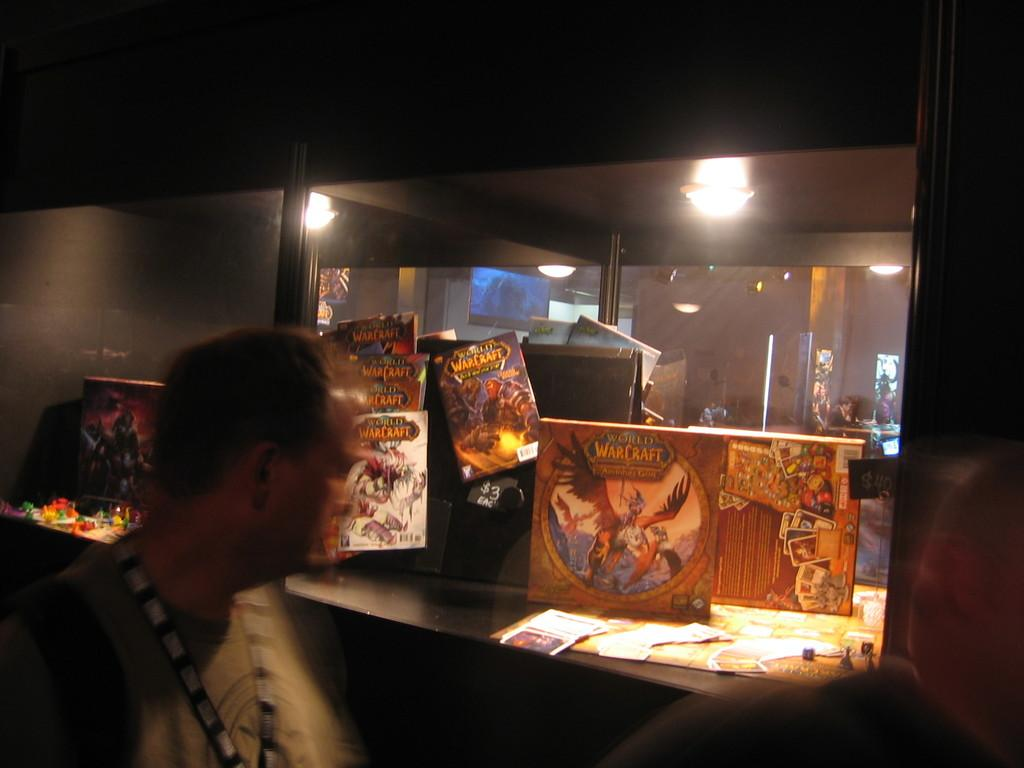What is located on the left side of the image? There is a man standing on the left side of the image, although the blurriness may affect the clarity of this observation. What can be seen in the image besides the man? There are some pictures and a light in the image, although the blurriness may affect the clarity of these observations. What type of bird can be seen on the man's neck in the image? There is no bird visible on the man's neck in the image. What kind of stamp is present on the man's forehead in the image? There is no stamp present on the man's forehead in the image. 